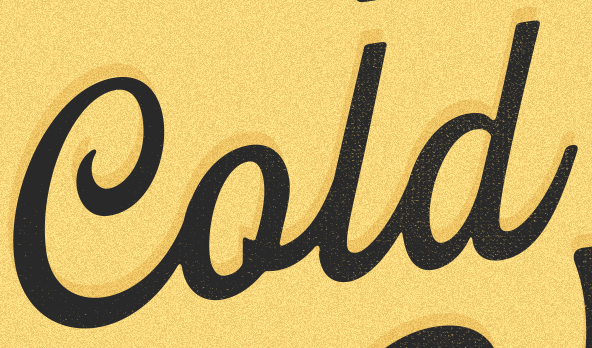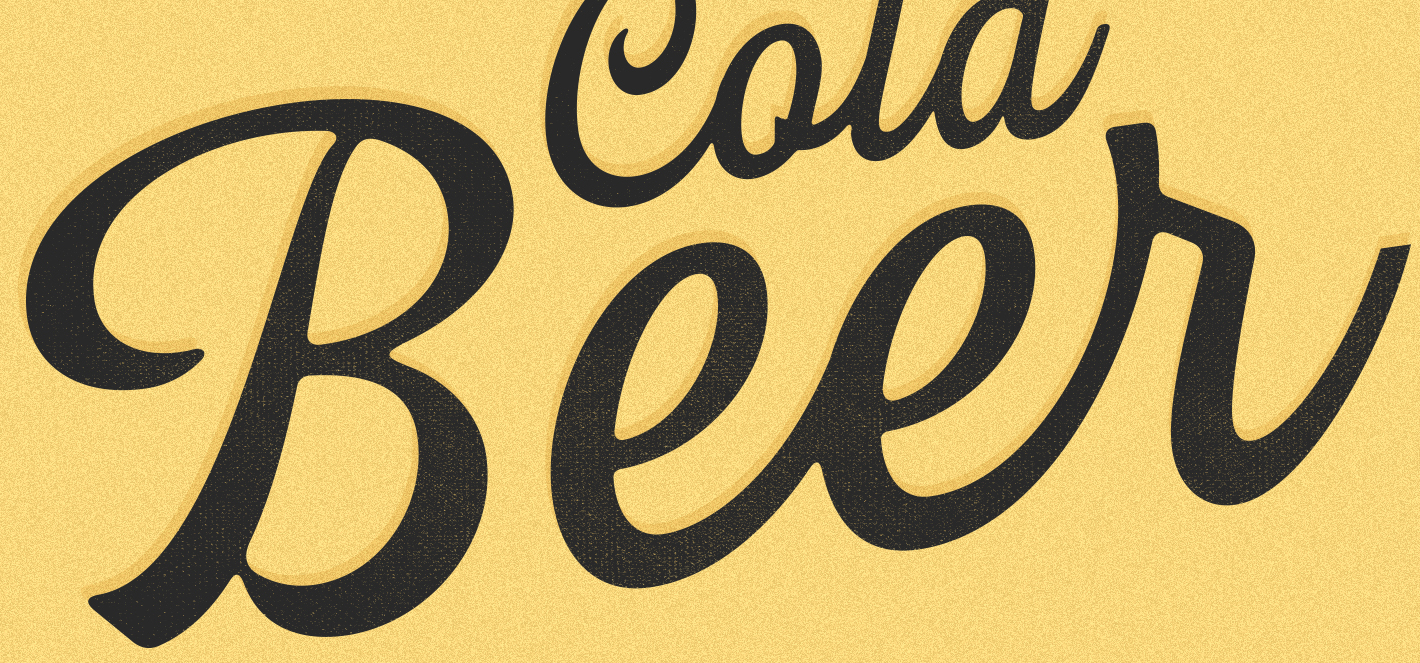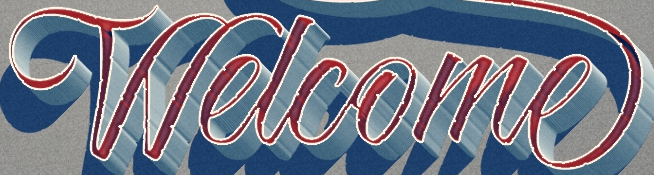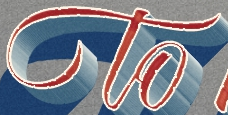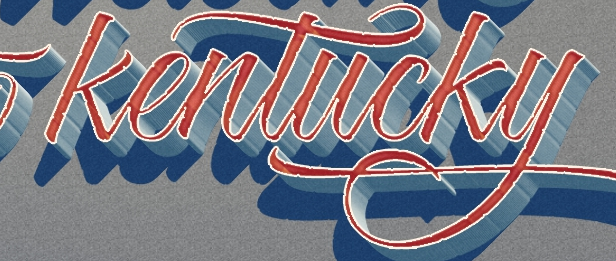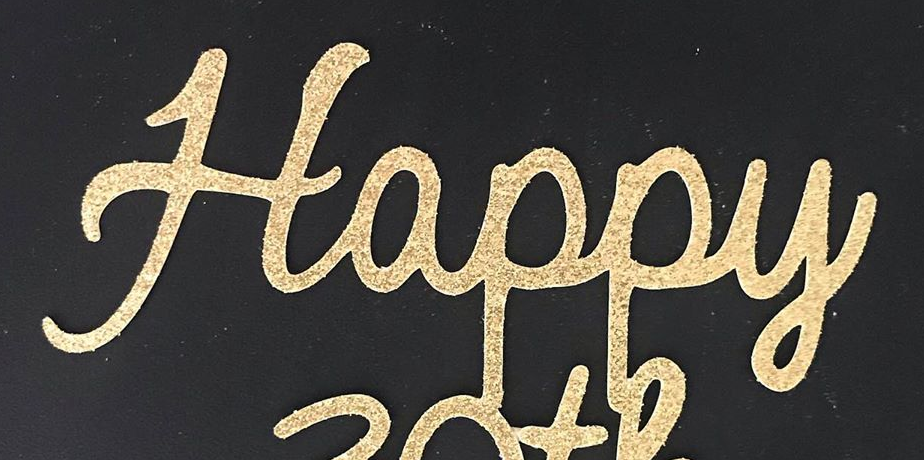What words can you see in these images in sequence, separated by a semicolon? Cold; Beer; Welcome; to; kentucky; Happy 